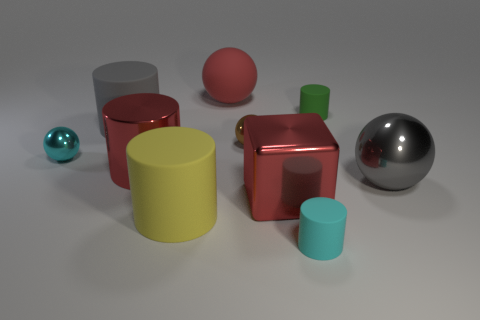There is a gray thing that is the same size as the gray matte cylinder; what is it made of?
Provide a succinct answer. Metal. What shape is the cyan object that is in front of the small cyan sphere?
Give a very brief answer. Cylinder. Are there fewer blocks that are left of the tiny brown shiny object than spheres that are right of the metallic block?
Give a very brief answer. Yes. Do the gray ball and the metal object in front of the gray ball have the same size?
Your answer should be compact. Yes. What number of cyan matte things have the same size as the brown thing?
Make the answer very short. 1. The large ball that is the same material as the small green thing is what color?
Keep it short and to the point. Red. Are there more tiny cyan rubber cylinders than tiny red shiny cylinders?
Provide a succinct answer. Yes. Does the yellow thing have the same material as the big cube?
Keep it short and to the point. No. There is a gray thing that is the same material as the red cylinder; what shape is it?
Your answer should be very brief. Sphere. Is the number of tiny brown things less than the number of large balls?
Offer a terse response. Yes. 